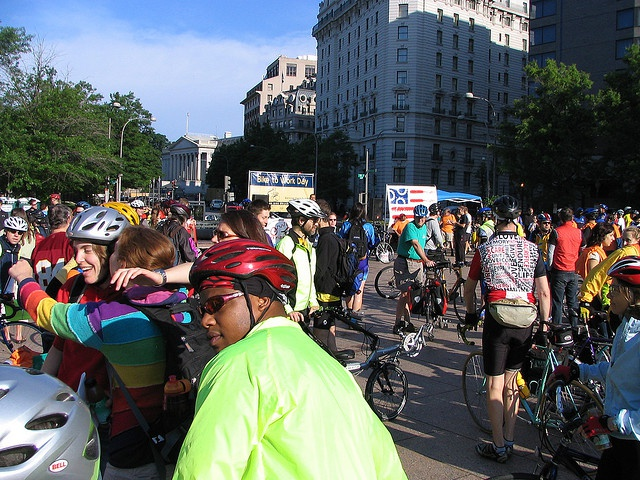Describe the objects in this image and their specific colors. I can see people in gray, black, white, and blue tones, people in gray, lightyellow, lightgreen, and black tones, people in gray, black, maroon, and navy tones, people in gray, black, white, and maroon tones, and car in gray, white, darkgray, and black tones in this image. 